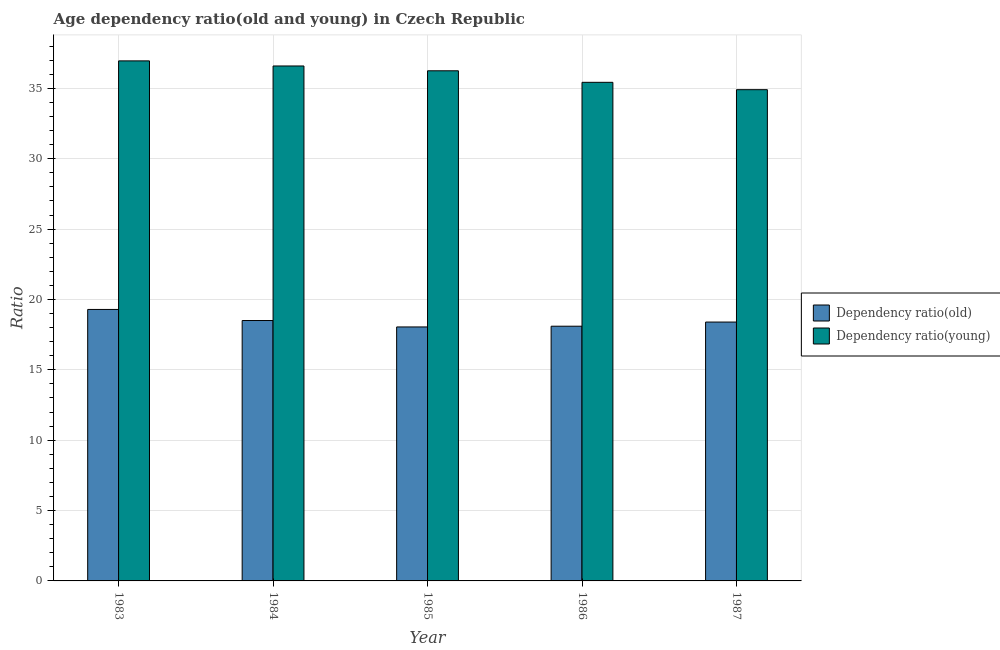What is the label of the 2nd group of bars from the left?
Give a very brief answer. 1984. In how many cases, is the number of bars for a given year not equal to the number of legend labels?
Provide a short and direct response. 0. What is the age dependency ratio(old) in 1987?
Provide a succinct answer. 18.4. Across all years, what is the maximum age dependency ratio(young)?
Your response must be concise. 36.96. Across all years, what is the minimum age dependency ratio(old)?
Provide a succinct answer. 18.05. In which year was the age dependency ratio(young) maximum?
Provide a short and direct response. 1983. In which year was the age dependency ratio(old) minimum?
Ensure brevity in your answer.  1985. What is the total age dependency ratio(old) in the graph?
Keep it short and to the point. 92.34. What is the difference between the age dependency ratio(young) in 1986 and that in 1987?
Provide a succinct answer. 0.52. What is the difference between the age dependency ratio(young) in 1985 and the age dependency ratio(old) in 1984?
Offer a very short reply. -0.34. What is the average age dependency ratio(young) per year?
Ensure brevity in your answer.  36.03. In how many years, is the age dependency ratio(old) greater than 37?
Offer a very short reply. 0. What is the ratio of the age dependency ratio(old) in 1984 to that in 1985?
Provide a short and direct response. 1.03. Is the age dependency ratio(old) in 1984 less than that in 1985?
Your response must be concise. No. What is the difference between the highest and the second highest age dependency ratio(old)?
Provide a short and direct response. 0.79. What is the difference between the highest and the lowest age dependency ratio(old)?
Your answer should be compact. 1.24. What does the 1st bar from the left in 1983 represents?
Provide a short and direct response. Dependency ratio(old). What does the 2nd bar from the right in 1987 represents?
Ensure brevity in your answer.  Dependency ratio(old). How many bars are there?
Your answer should be compact. 10. Are all the bars in the graph horizontal?
Offer a very short reply. No. How many years are there in the graph?
Your response must be concise. 5. What is the difference between two consecutive major ticks on the Y-axis?
Make the answer very short. 5. Are the values on the major ticks of Y-axis written in scientific E-notation?
Your answer should be compact. No. Where does the legend appear in the graph?
Your answer should be very brief. Center right. How many legend labels are there?
Your answer should be compact. 2. What is the title of the graph?
Your answer should be compact. Age dependency ratio(old and young) in Czech Republic. What is the label or title of the X-axis?
Your answer should be compact. Year. What is the label or title of the Y-axis?
Your answer should be compact. Ratio. What is the Ratio of Dependency ratio(old) in 1983?
Your answer should be compact. 19.29. What is the Ratio of Dependency ratio(young) in 1983?
Provide a succinct answer. 36.96. What is the Ratio of Dependency ratio(old) in 1984?
Your response must be concise. 18.5. What is the Ratio of Dependency ratio(young) in 1984?
Your answer should be compact. 36.59. What is the Ratio of Dependency ratio(old) in 1985?
Keep it short and to the point. 18.05. What is the Ratio in Dependency ratio(young) in 1985?
Your response must be concise. 36.25. What is the Ratio in Dependency ratio(old) in 1986?
Give a very brief answer. 18.1. What is the Ratio in Dependency ratio(young) in 1986?
Offer a very short reply. 35.43. What is the Ratio in Dependency ratio(old) in 1987?
Provide a succinct answer. 18.4. What is the Ratio of Dependency ratio(young) in 1987?
Your response must be concise. 34.91. Across all years, what is the maximum Ratio of Dependency ratio(old)?
Offer a terse response. 19.29. Across all years, what is the maximum Ratio of Dependency ratio(young)?
Provide a short and direct response. 36.96. Across all years, what is the minimum Ratio in Dependency ratio(old)?
Your answer should be compact. 18.05. Across all years, what is the minimum Ratio of Dependency ratio(young)?
Your answer should be very brief. 34.91. What is the total Ratio in Dependency ratio(old) in the graph?
Provide a succinct answer. 92.34. What is the total Ratio of Dependency ratio(young) in the graph?
Provide a short and direct response. 180.14. What is the difference between the Ratio in Dependency ratio(old) in 1983 and that in 1984?
Ensure brevity in your answer.  0.79. What is the difference between the Ratio of Dependency ratio(young) in 1983 and that in 1984?
Your answer should be compact. 0.36. What is the difference between the Ratio of Dependency ratio(old) in 1983 and that in 1985?
Ensure brevity in your answer.  1.24. What is the difference between the Ratio in Dependency ratio(young) in 1983 and that in 1985?
Your answer should be compact. 0.7. What is the difference between the Ratio in Dependency ratio(old) in 1983 and that in 1986?
Provide a short and direct response. 1.19. What is the difference between the Ratio of Dependency ratio(young) in 1983 and that in 1986?
Your answer should be very brief. 1.52. What is the difference between the Ratio of Dependency ratio(old) in 1983 and that in 1987?
Keep it short and to the point. 0.9. What is the difference between the Ratio in Dependency ratio(young) in 1983 and that in 1987?
Make the answer very short. 2.05. What is the difference between the Ratio of Dependency ratio(old) in 1984 and that in 1985?
Offer a terse response. 0.46. What is the difference between the Ratio of Dependency ratio(young) in 1984 and that in 1985?
Your answer should be very brief. 0.34. What is the difference between the Ratio of Dependency ratio(old) in 1984 and that in 1986?
Offer a terse response. 0.4. What is the difference between the Ratio of Dependency ratio(young) in 1984 and that in 1986?
Offer a very short reply. 1.16. What is the difference between the Ratio in Dependency ratio(old) in 1984 and that in 1987?
Provide a succinct answer. 0.11. What is the difference between the Ratio of Dependency ratio(young) in 1984 and that in 1987?
Keep it short and to the point. 1.69. What is the difference between the Ratio of Dependency ratio(old) in 1985 and that in 1986?
Give a very brief answer. -0.05. What is the difference between the Ratio of Dependency ratio(young) in 1985 and that in 1986?
Ensure brevity in your answer.  0.82. What is the difference between the Ratio of Dependency ratio(old) in 1985 and that in 1987?
Ensure brevity in your answer.  -0.35. What is the difference between the Ratio in Dependency ratio(young) in 1985 and that in 1987?
Ensure brevity in your answer.  1.34. What is the difference between the Ratio of Dependency ratio(old) in 1986 and that in 1987?
Your answer should be very brief. -0.3. What is the difference between the Ratio in Dependency ratio(young) in 1986 and that in 1987?
Provide a short and direct response. 0.52. What is the difference between the Ratio of Dependency ratio(old) in 1983 and the Ratio of Dependency ratio(young) in 1984?
Your answer should be very brief. -17.3. What is the difference between the Ratio in Dependency ratio(old) in 1983 and the Ratio in Dependency ratio(young) in 1985?
Offer a very short reply. -16.96. What is the difference between the Ratio of Dependency ratio(old) in 1983 and the Ratio of Dependency ratio(young) in 1986?
Provide a short and direct response. -16.14. What is the difference between the Ratio of Dependency ratio(old) in 1983 and the Ratio of Dependency ratio(young) in 1987?
Give a very brief answer. -15.62. What is the difference between the Ratio of Dependency ratio(old) in 1984 and the Ratio of Dependency ratio(young) in 1985?
Provide a short and direct response. -17.75. What is the difference between the Ratio of Dependency ratio(old) in 1984 and the Ratio of Dependency ratio(young) in 1986?
Give a very brief answer. -16.93. What is the difference between the Ratio in Dependency ratio(old) in 1984 and the Ratio in Dependency ratio(young) in 1987?
Your answer should be compact. -16.4. What is the difference between the Ratio in Dependency ratio(old) in 1985 and the Ratio in Dependency ratio(young) in 1986?
Offer a terse response. -17.38. What is the difference between the Ratio in Dependency ratio(old) in 1985 and the Ratio in Dependency ratio(young) in 1987?
Offer a terse response. -16.86. What is the difference between the Ratio of Dependency ratio(old) in 1986 and the Ratio of Dependency ratio(young) in 1987?
Offer a terse response. -16.81. What is the average Ratio in Dependency ratio(old) per year?
Your response must be concise. 18.47. What is the average Ratio of Dependency ratio(young) per year?
Your answer should be compact. 36.03. In the year 1983, what is the difference between the Ratio in Dependency ratio(old) and Ratio in Dependency ratio(young)?
Ensure brevity in your answer.  -17.66. In the year 1984, what is the difference between the Ratio of Dependency ratio(old) and Ratio of Dependency ratio(young)?
Make the answer very short. -18.09. In the year 1985, what is the difference between the Ratio in Dependency ratio(old) and Ratio in Dependency ratio(young)?
Offer a very short reply. -18.2. In the year 1986, what is the difference between the Ratio of Dependency ratio(old) and Ratio of Dependency ratio(young)?
Give a very brief answer. -17.33. In the year 1987, what is the difference between the Ratio of Dependency ratio(old) and Ratio of Dependency ratio(young)?
Provide a succinct answer. -16.51. What is the ratio of the Ratio in Dependency ratio(old) in 1983 to that in 1984?
Your response must be concise. 1.04. What is the ratio of the Ratio of Dependency ratio(young) in 1983 to that in 1984?
Provide a short and direct response. 1.01. What is the ratio of the Ratio in Dependency ratio(old) in 1983 to that in 1985?
Provide a short and direct response. 1.07. What is the ratio of the Ratio in Dependency ratio(young) in 1983 to that in 1985?
Your answer should be very brief. 1.02. What is the ratio of the Ratio of Dependency ratio(old) in 1983 to that in 1986?
Your answer should be compact. 1.07. What is the ratio of the Ratio in Dependency ratio(young) in 1983 to that in 1986?
Make the answer very short. 1.04. What is the ratio of the Ratio of Dependency ratio(old) in 1983 to that in 1987?
Provide a succinct answer. 1.05. What is the ratio of the Ratio of Dependency ratio(young) in 1983 to that in 1987?
Ensure brevity in your answer.  1.06. What is the ratio of the Ratio in Dependency ratio(old) in 1984 to that in 1985?
Your response must be concise. 1.03. What is the ratio of the Ratio in Dependency ratio(young) in 1984 to that in 1985?
Your response must be concise. 1.01. What is the ratio of the Ratio in Dependency ratio(old) in 1984 to that in 1986?
Make the answer very short. 1.02. What is the ratio of the Ratio in Dependency ratio(young) in 1984 to that in 1986?
Provide a short and direct response. 1.03. What is the ratio of the Ratio in Dependency ratio(old) in 1984 to that in 1987?
Your response must be concise. 1.01. What is the ratio of the Ratio of Dependency ratio(young) in 1984 to that in 1987?
Your answer should be very brief. 1.05. What is the ratio of the Ratio in Dependency ratio(old) in 1985 to that in 1986?
Give a very brief answer. 1. What is the ratio of the Ratio in Dependency ratio(young) in 1985 to that in 1986?
Give a very brief answer. 1.02. What is the ratio of the Ratio of Dependency ratio(old) in 1985 to that in 1987?
Give a very brief answer. 0.98. What is the ratio of the Ratio in Dependency ratio(old) in 1986 to that in 1987?
Provide a short and direct response. 0.98. What is the difference between the highest and the second highest Ratio of Dependency ratio(old)?
Your response must be concise. 0.79. What is the difference between the highest and the second highest Ratio in Dependency ratio(young)?
Give a very brief answer. 0.36. What is the difference between the highest and the lowest Ratio in Dependency ratio(old)?
Give a very brief answer. 1.24. What is the difference between the highest and the lowest Ratio in Dependency ratio(young)?
Keep it short and to the point. 2.05. 